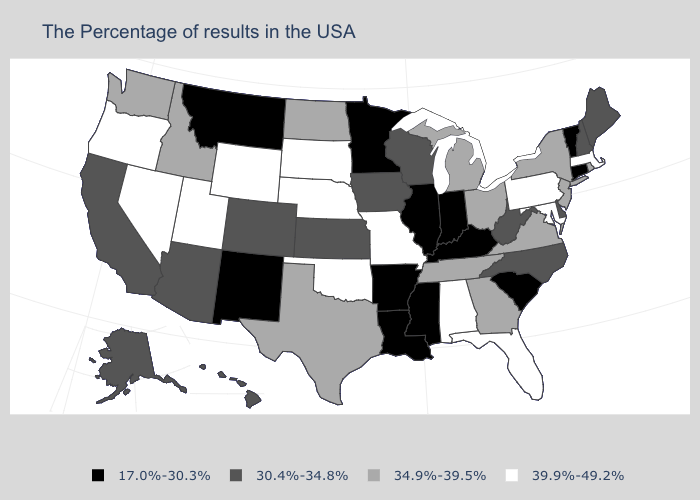What is the value of New Jersey?
Keep it brief. 34.9%-39.5%. What is the value of Indiana?
Be succinct. 17.0%-30.3%. Name the states that have a value in the range 17.0%-30.3%?
Short answer required. Vermont, Connecticut, South Carolina, Kentucky, Indiana, Illinois, Mississippi, Louisiana, Arkansas, Minnesota, New Mexico, Montana. What is the lowest value in the West?
Give a very brief answer. 17.0%-30.3%. What is the value of Kentucky?
Concise answer only. 17.0%-30.3%. What is the highest value in the MidWest ?
Keep it brief. 39.9%-49.2%. Name the states that have a value in the range 34.9%-39.5%?
Keep it brief. Rhode Island, New York, New Jersey, Virginia, Ohio, Georgia, Michigan, Tennessee, Texas, North Dakota, Idaho, Washington. Does the first symbol in the legend represent the smallest category?
Quick response, please. Yes. What is the value of Rhode Island?
Quick response, please. 34.9%-39.5%. Among the states that border South Dakota , does Nebraska have the highest value?
Short answer required. Yes. Name the states that have a value in the range 17.0%-30.3%?
Write a very short answer. Vermont, Connecticut, South Carolina, Kentucky, Indiana, Illinois, Mississippi, Louisiana, Arkansas, Minnesota, New Mexico, Montana. What is the value of Ohio?
Concise answer only. 34.9%-39.5%. What is the highest value in states that border New Mexico?
Quick response, please. 39.9%-49.2%. Name the states that have a value in the range 34.9%-39.5%?
Keep it brief. Rhode Island, New York, New Jersey, Virginia, Ohio, Georgia, Michigan, Tennessee, Texas, North Dakota, Idaho, Washington. Name the states that have a value in the range 30.4%-34.8%?
Write a very short answer. Maine, New Hampshire, Delaware, North Carolina, West Virginia, Wisconsin, Iowa, Kansas, Colorado, Arizona, California, Alaska, Hawaii. 